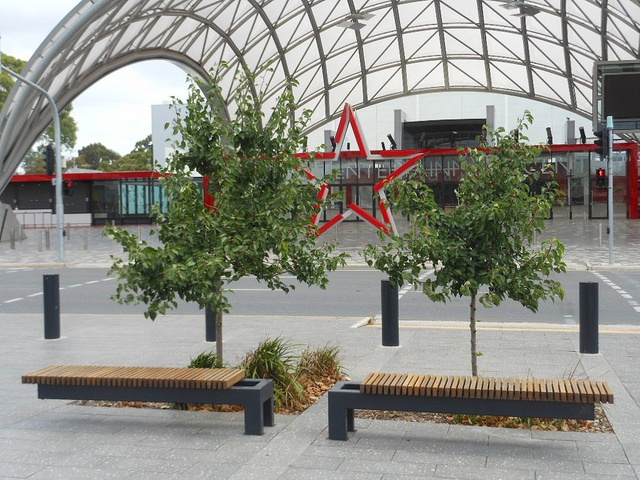Describe the objects in this image and their specific colors. I can see bench in white, black, maroon, tan, and darkgray tones, bench in white, black, tan, maroon, and gray tones, traffic light in white, black, maroon, gray, and purple tones, traffic light in white, black, and gray tones, and traffic light in white, black, gray, and purple tones in this image. 